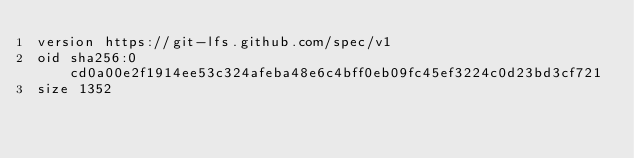<code> <loc_0><loc_0><loc_500><loc_500><_SQL_>version https://git-lfs.github.com/spec/v1
oid sha256:0cd0a00e2f1914ee53c324afeba48e6c4bff0eb09fc45ef3224c0d23bd3cf721
size 1352
</code> 